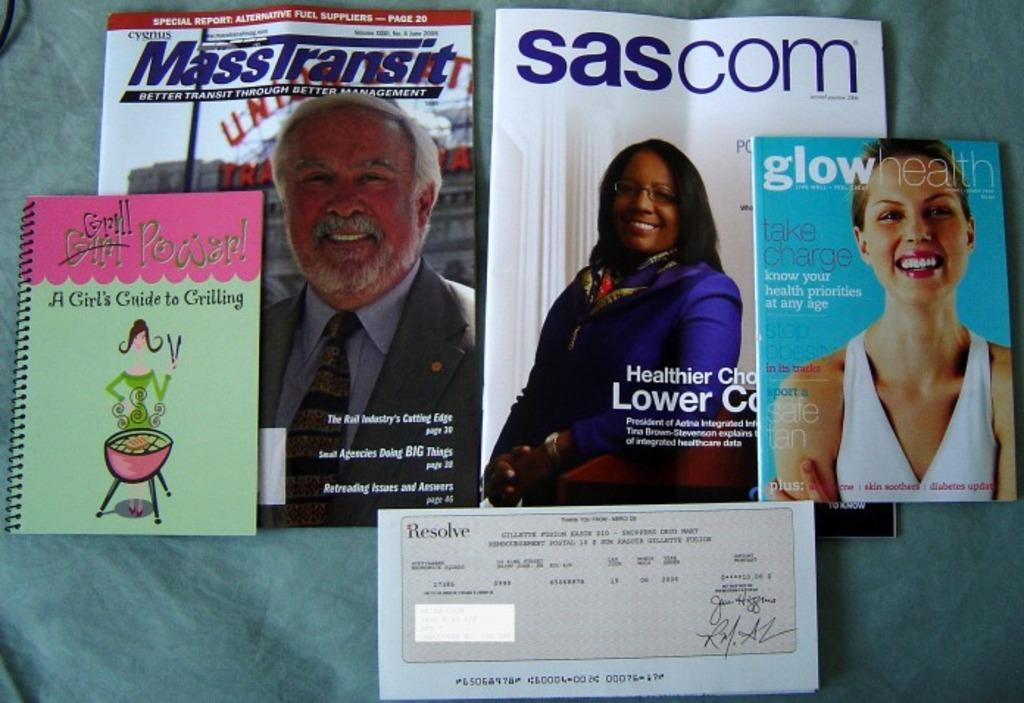How many books are on the table in the image? There are four books on the table in the image. What can be seen on the cover pages of the books? The books have images of a man and a woman on their cover pages. What is located at the bottom of the table? There is a paper at the bottom of the table. What type of meat is being served on the bun in the image? There is no bun or meat present in the image; it only features four books with images of a man and a woman on their cover pages and a paper at the bottom of the table. 